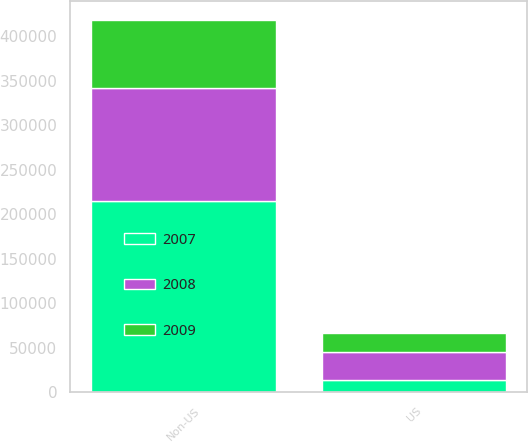Convert chart. <chart><loc_0><loc_0><loc_500><loc_500><stacked_bar_chart><ecel><fcel>US<fcel>Non-US<nl><fcel>2007<fcel>13755<fcel>215439<nl><fcel>2008<fcel>31783<fcel>126072<nl><fcel>2009<fcel>21219<fcel>76754<nl></chart> 